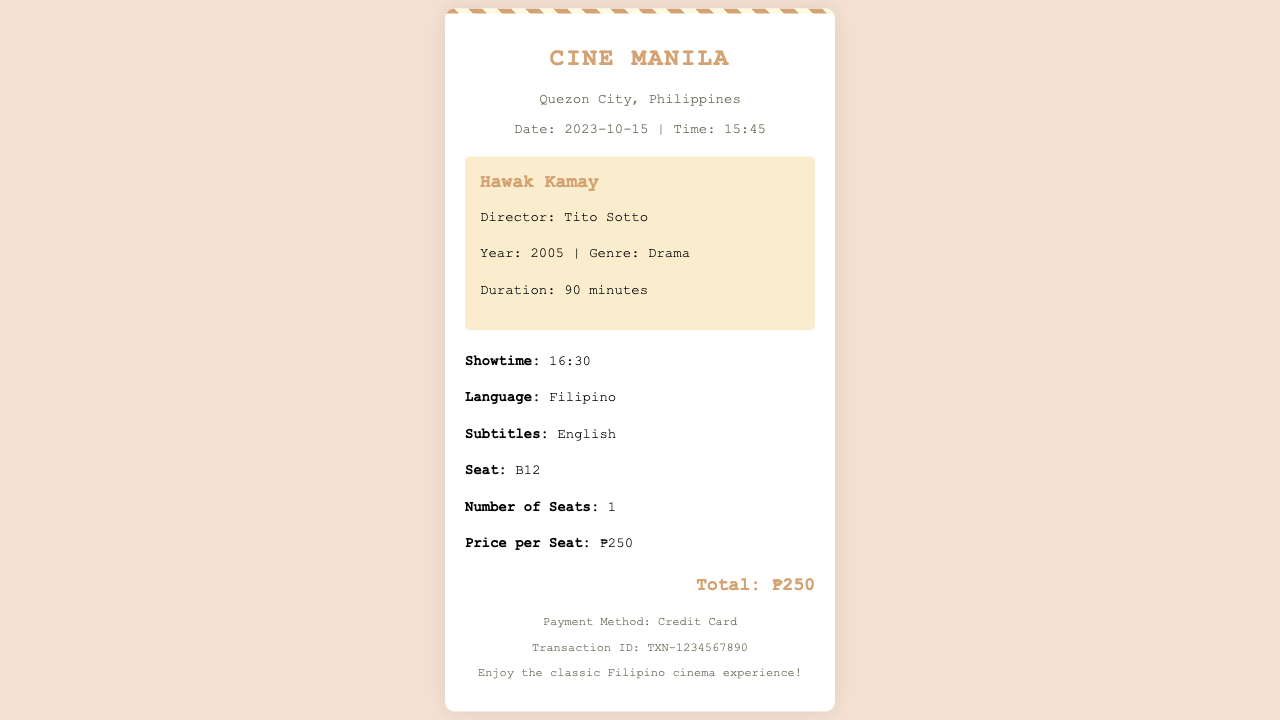What is the movie title? The title of the movie can be found in the movie information section of the receipt.
Answer: Hawak Kamay Who is the director of the movie? The director's name is provided in the movie details section.
Answer: Tito Sotto What is the showtime of the movie? The showtime is explicitly mentioned in the showtime details.
Answer: 16:30 What is the seat number? The seat number is listed in the seat details section of the receipt.
Answer: B12 How much does one seat cost? The price per seat is indicated in the seat details portion of the document.
Answer: ₱250 What genre is the movie? The genre of the film is stated in the movie details section of the receipt.
Answer: Drama What is the date of the ticket purchase? The date can be found in the theater information section of the receipt.
Answer: 2023-10-15 How many seats were purchased? The number of seats purchased is specified in the seat details section.
Answer: 1 What payment method was used? The payment method is outlined in the footer of the receipt.
Answer: Credit Card 